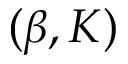<formula> <loc_0><loc_0><loc_500><loc_500>( \beta , K )</formula> 